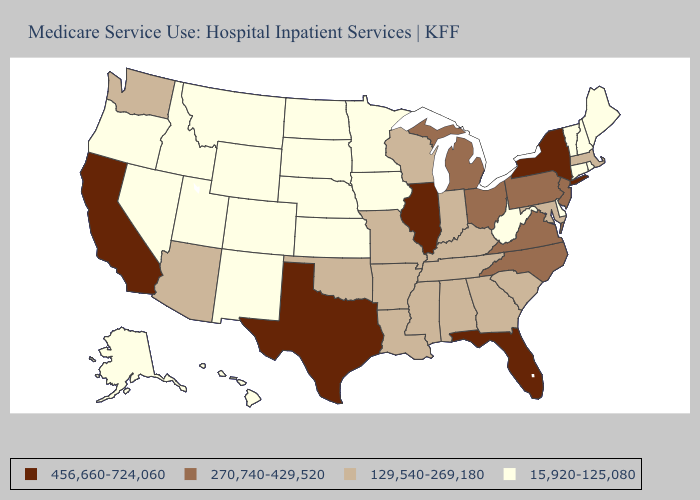Does Louisiana have the highest value in the USA?
Keep it brief. No. What is the lowest value in the Northeast?
Short answer required. 15,920-125,080. Name the states that have a value in the range 15,920-125,080?
Quick response, please. Alaska, Colorado, Connecticut, Delaware, Hawaii, Idaho, Iowa, Kansas, Maine, Minnesota, Montana, Nebraska, Nevada, New Hampshire, New Mexico, North Dakota, Oregon, Rhode Island, South Dakota, Utah, Vermont, West Virginia, Wyoming. Name the states that have a value in the range 270,740-429,520?
Give a very brief answer. Michigan, New Jersey, North Carolina, Ohio, Pennsylvania, Virginia. Among the states that border Minnesota , which have the highest value?
Write a very short answer. Wisconsin. Which states have the lowest value in the MidWest?
Give a very brief answer. Iowa, Kansas, Minnesota, Nebraska, North Dakota, South Dakota. Does Oregon have the lowest value in the USA?
Concise answer only. Yes. Does Illinois have a higher value than New Jersey?
Quick response, please. Yes. What is the value of Delaware?
Short answer required. 15,920-125,080. What is the value of California?
Quick response, please. 456,660-724,060. Which states hav the highest value in the South?
Short answer required. Florida, Texas. Does Rhode Island have the lowest value in the USA?
Keep it brief. Yes. What is the highest value in the South ?
Give a very brief answer. 456,660-724,060. What is the highest value in states that border Ohio?
Short answer required. 270,740-429,520. Does New Jersey have the highest value in the Northeast?
Keep it brief. No. 